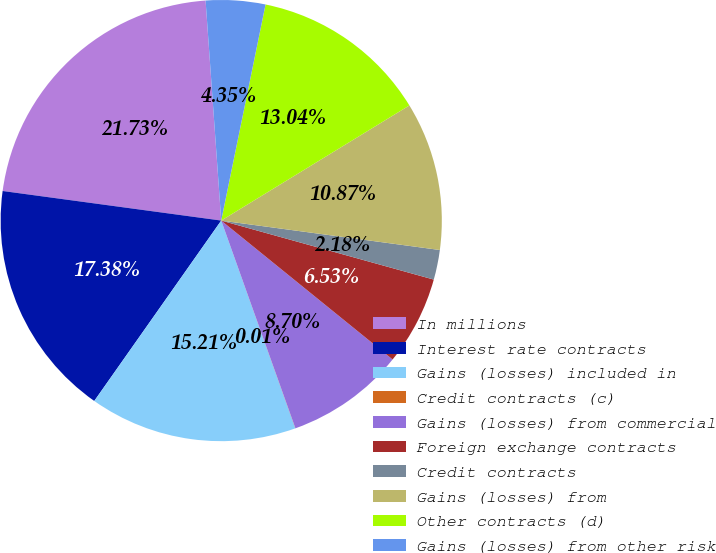Convert chart to OTSL. <chart><loc_0><loc_0><loc_500><loc_500><pie_chart><fcel>In millions<fcel>Interest rate contracts<fcel>Gains (losses) included in<fcel>Credit contracts (c)<fcel>Gains (losses) from commercial<fcel>Foreign exchange contracts<fcel>Credit contracts<fcel>Gains (losses) from<fcel>Other contracts (d)<fcel>Gains (losses) from other risk<nl><fcel>21.73%<fcel>17.38%<fcel>15.21%<fcel>0.01%<fcel>8.7%<fcel>6.53%<fcel>2.18%<fcel>10.87%<fcel>13.04%<fcel>4.35%<nl></chart> 